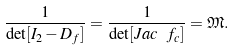Convert formula to latex. <formula><loc_0><loc_0><loc_500><loc_500>\frac { 1 } { \det [ I _ { 2 } - D _ { f } ] } = \frac { 1 } { \det [ J a c \ f _ { c } ] } = \mathfrak { M } .</formula> 